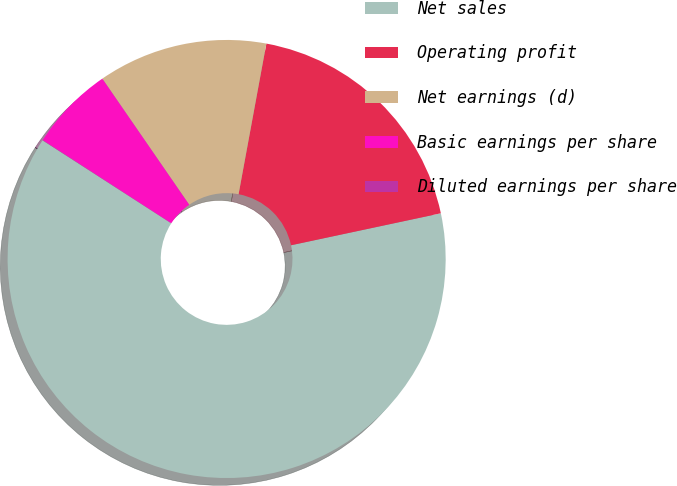<chart> <loc_0><loc_0><loc_500><loc_500><pie_chart><fcel>Net sales<fcel>Operating profit<fcel>Net earnings (d)<fcel>Basic earnings per share<fcel>Diluted earnings per share<nl><fcel>62.46%<fcel>18.75%<fcel>12.51%<fcel>6.26%<fcel>0.02%<nl></chart> 